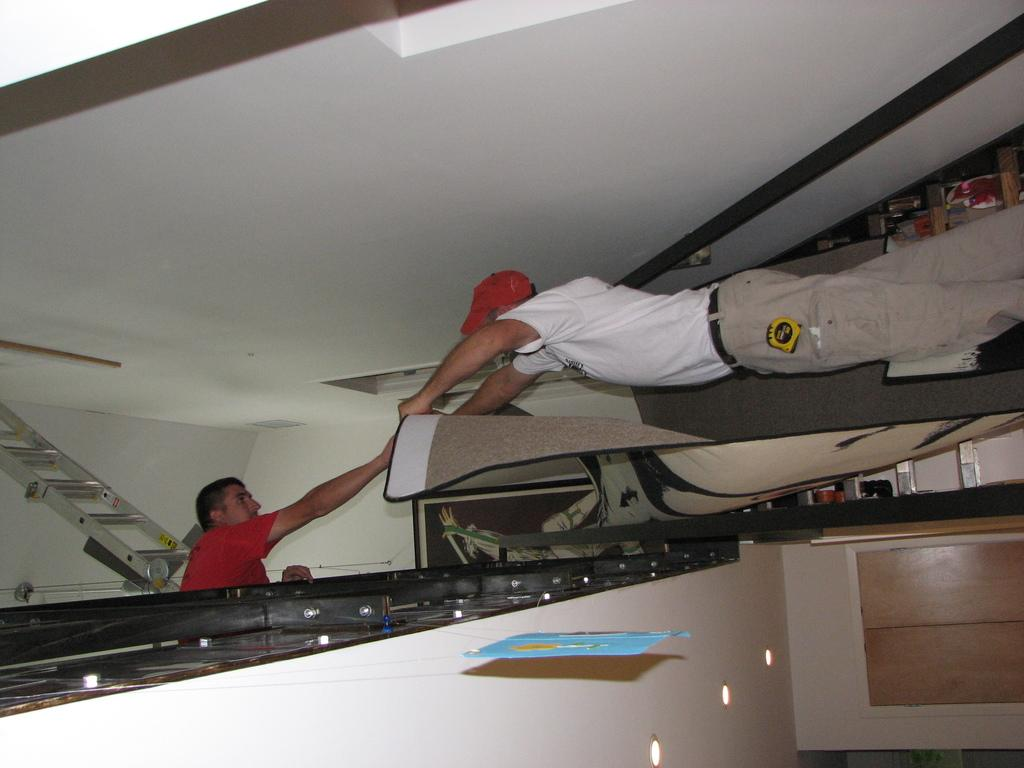How many people are in the image? There are two people in the image. What object can be seen in the image that is used for climbing or reaching high places? There is a ladder in the image. What recreational item is visible in the image? There is a kite in the image. What type of structure is depicted in the image? The image includes a roof and walls. What can be seen in the image that provides illumination? There are lights in the image. Can you describe any other objects in the image that were not specified? There are some unspecified objects in the image. Reasoning: Let's think step by step by step in order to produce the conversation. We start by identifying the number of people in the image, which is two. Then, we describe specific objects and features that are visible, such as the ladder, kite, roof, walls, and lights. We also acknowledge the presence of unspecified objects, which allows for further discussion if more information becomes available. Absurd Question/Answer: What type of locket is hanging from the kite in the image? There is no locket hanging from the kite in the image; only the kite itself is visible. What type of metal is the ladder made of in the image? The image does not specify the material of the ladder, so it cannot be determined from the image. 